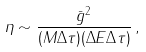<formula> <loc_0><loc_0><loc_500><loc_500>\eta \sim \frac { \bar { g } ^ { 2 } } { ( M \Delta \tau ) ( \Delta E \Delta \tau ) } \, ,</formula> 